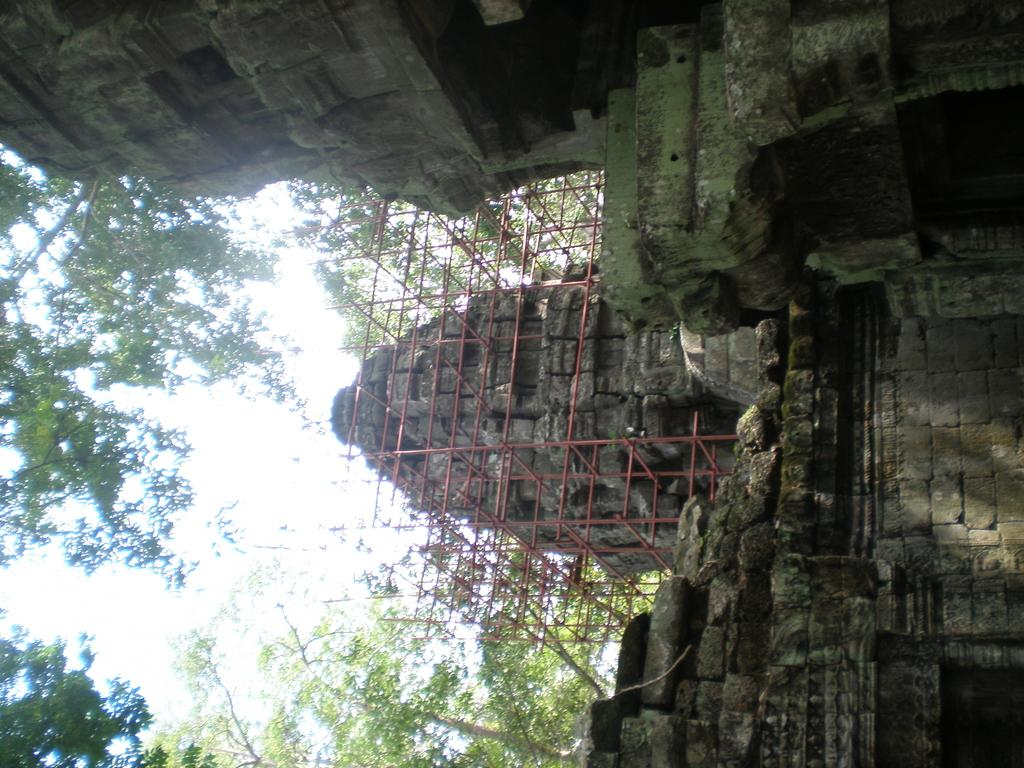What type of structure is present in the image? There is a building in the image. What is the color of the building? The building is gray in color. What can be seen in the background of the image? There are trees in the background of the image. What is the color of the trees? The trees are green in color. What is visible above the building and trees? The sky is visible in the image. What is the color of the sky? The sky is white in color. Can you hear the deer in the image? There are no deer present in the image, so it is not possible to hear them. 